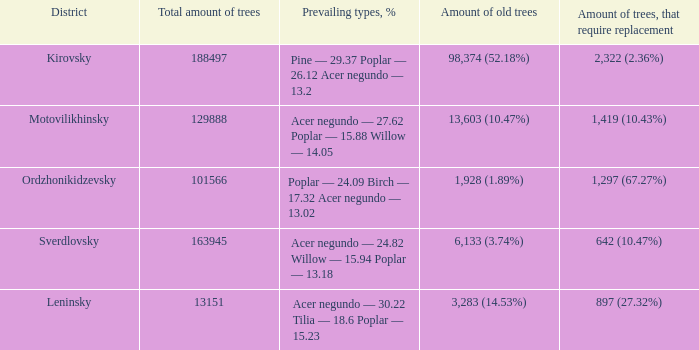What is the district when the total amount of trees is smaller than 150817.6878461314 and amount of old trees is 1,928 (1.89%)? Ordzhonikidzevsky. 